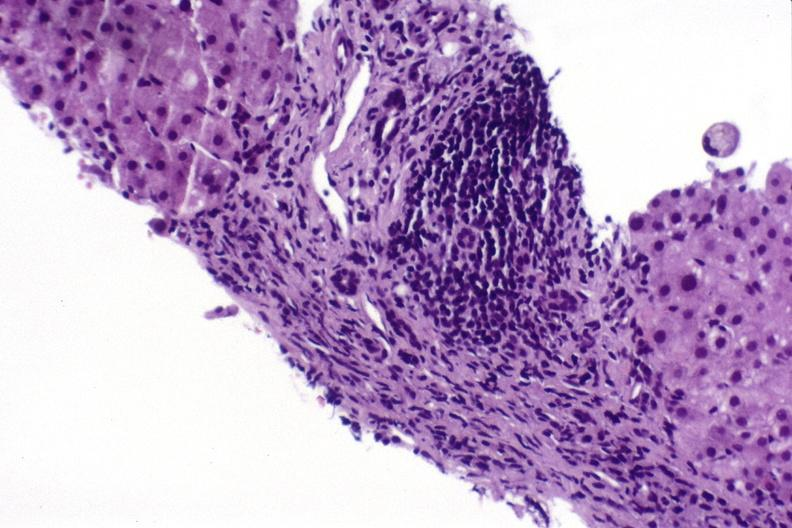does this image show hepatitis c virus?
Answer the question using a single word or phrase. Yes 